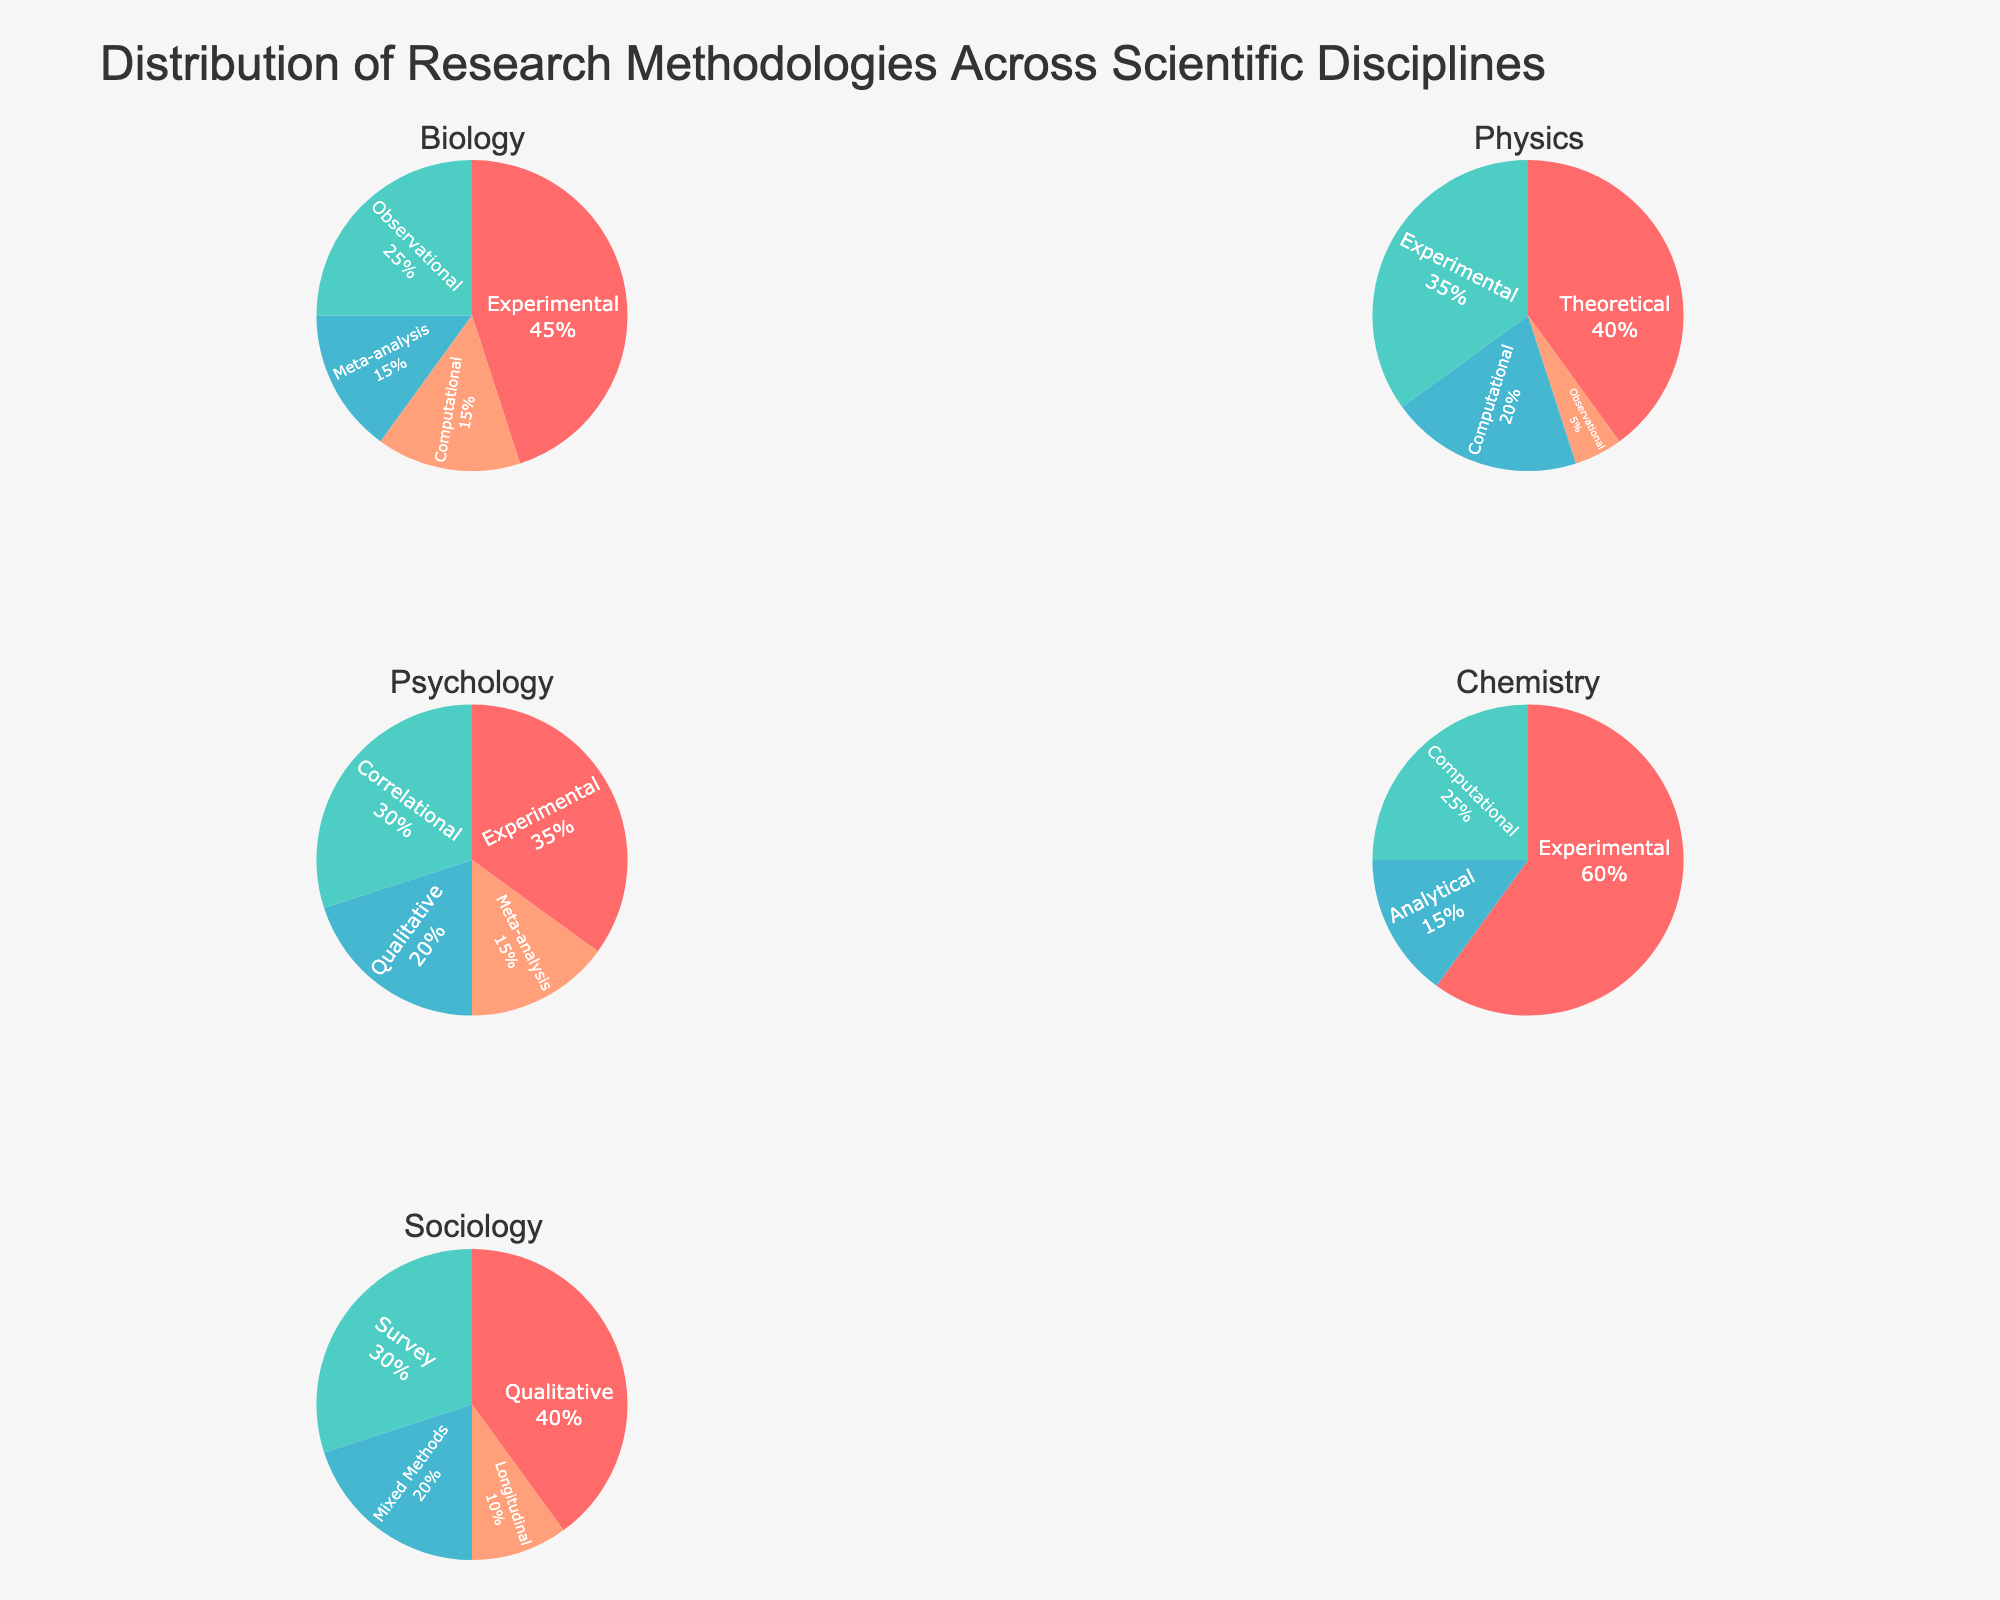How many categories of government funding are displayed in the figure? The subplot titles indicate five categories: Domestic Violence Prevention, Refugee Assistance, Indigenous Rights, LGBTQ+ Equality, and Disability Rights.
Answer: Five What's the average allocation percentage for Legal Aid across all categories? Legal Aid percentages are 25, 30, 20, 15, and 20. Sum is 25 + 30 + 20 + 15 + 20 = 110. The average is 110 / 5 = 22.
Answer: 22% Which category allocates the highest percentage to Healthcare? In the Healthcare slice across categories, Disability Rights allocates the most at 30%.
Answer: Disability Rights Comparing Domestic Violence Prevention and LGBTQ+ Equality, which allocates a higher percentage to Advocacy? Domestic Violence Prevention allocates 30% and LGBTQ+ Equality allocates 30%. Hence, they are equal in Advocacy allocation.
Answer: Equal What's the total allocation percentage to Research across all categories? Research percentages are 10, 10, 10, 10, and 10. Sum is 5 * 10 = 50.
Answer: 50% Which funding category has the most evenly distributed allocations? Compare ratios and variances; Refugee Assistance has closer and more balanced values: 30, 25, 20, 15, 10.
Answer: Refugee Assistance In Refugee Assistance, is the money spent on Legal Aid greater than the money spent on Education and Healthcare combined? Legal Aid is 30%. Education and Healthcare are 25% + 20% = 45%. Legal Aid (30%) is not greater than the combined (45%).
Answer: No How does the proportion of Education funding in Indigenous Rights compare to Domestic Violence Prevention? Indigenous Rights allocates 30% to Education, Domestic Violence Prevention allocates 20%. Indigenous Rights has a higher percentage.
Answer: Indigenous Rights What percentage of total funding is allocated to Advocacy across Domestic Violence Prevention and LGBTQ+ Equality combined? Domestic Violence Prevention allocates 30% and LGBTQ+ Equality also allocates 30%. Combined, it's 30% + 30% = 60%.
Answer: 60% 